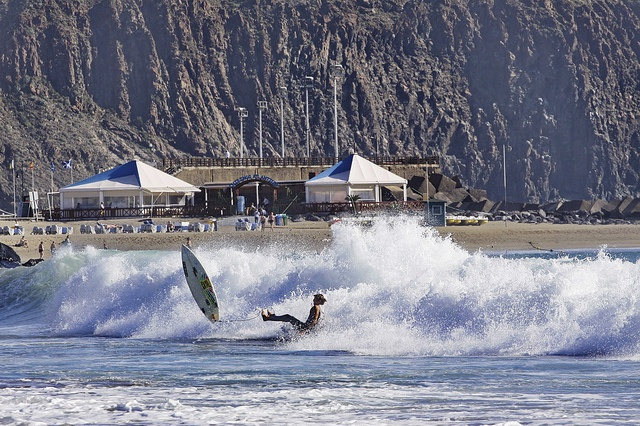Describe the objects in this image and their specific colors. I can see surfboard in gray, black, darkgray, and lightgray tones, people in gray, black, darkgray, and lightgray tones, people in gray, darkgray, and lightgray tones, people in gray, darkgray, and black tones, and people in gray, darkgray, and black tones in this image. 